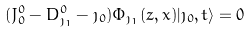<formula> <loc_0><loc_0><loc_500><loc_500>( J ^ { 0 } _ { 0 } - D ^ { 0 } _ { \jmath _ { 1 } } - \jmath _ { 0 } ) \Phi _ { \jmath _ { 1 } } ( z , x ) | \jmath _ { 0 } , t \rangle = 0</formula> 